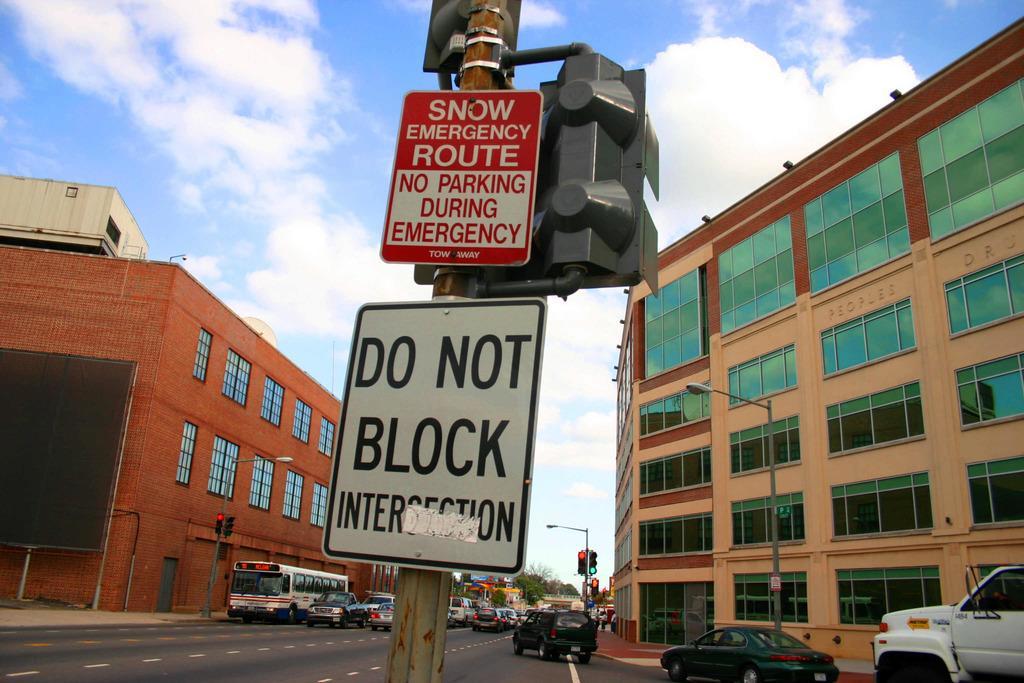Could you give a brief overview of what you see in this image? This picture is clicked outside the city. In front of the picture, we see traffic signals and two boards in red and white color with some text written on each board. On either side of the road, there are buildings, street lights and traffic signals. At the top of the picture, we see the sky and the clouds. 